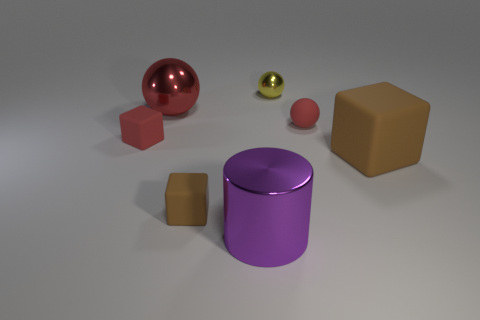Add 3 big purple shiny objects. How many objects exist? 10 Subtract all purple blocks. How many red spheres are left? 2 Subtract all small rubber cubes. How many cubes are left? 1 Subtract all cubes. How many objects are left? 4 Add 1 red metal spheres. How many red metal spheres exist? 2 Subtract all red cubes. How many cubes are left? 2 Subtract 0 brown cylinders. How many objects are left? 7 Subtract 1 spheres. How many spheres are left? 2 Subtract all green cubes. Subtract all cyan balls. How many cubes are left? 3 Subtract all big metal objects. Subtract all rubber blocks. How many objects are left? 2 